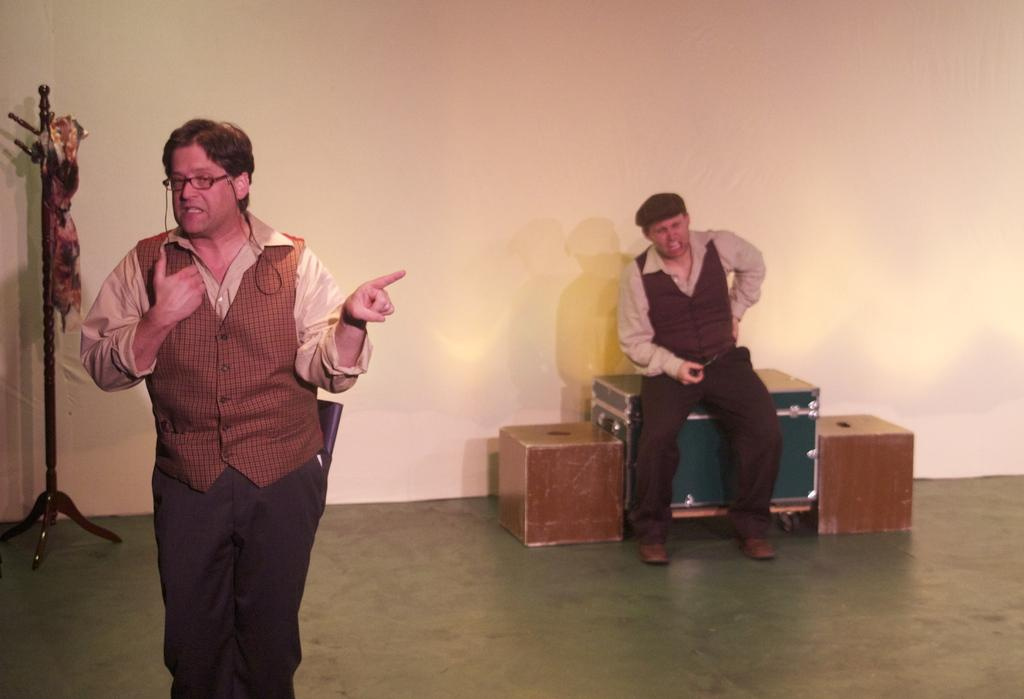What is the color of the wall in the image? The wall in the image is white. What can be seen in the image besides the wall? There is a stand, a cloth, boxes, and two persons in the image. Can you describe the stand in the image? The stand is a piece of furniture that is likely used for holding or displaying items. What is the cloth used for in the image? The cloth might be used for covering or protecting items on the stand or for decorative purposes. How many boxes are visible in the image? There are boxes in the image, but the exact number is not specified. How many people are in the image? There are two persons in the image. Where is one of the men located in the image? One man is standing on the left side of the image. What is the man wearing in the image? The man is wearing a red color jacket. How many lizards are crawling on the wall in the image? There are no lizards present in the image; the wall is white. What is the digestion process of the birthday cake in the image? There is no birthday cake or digestion process mentioned in the image. 